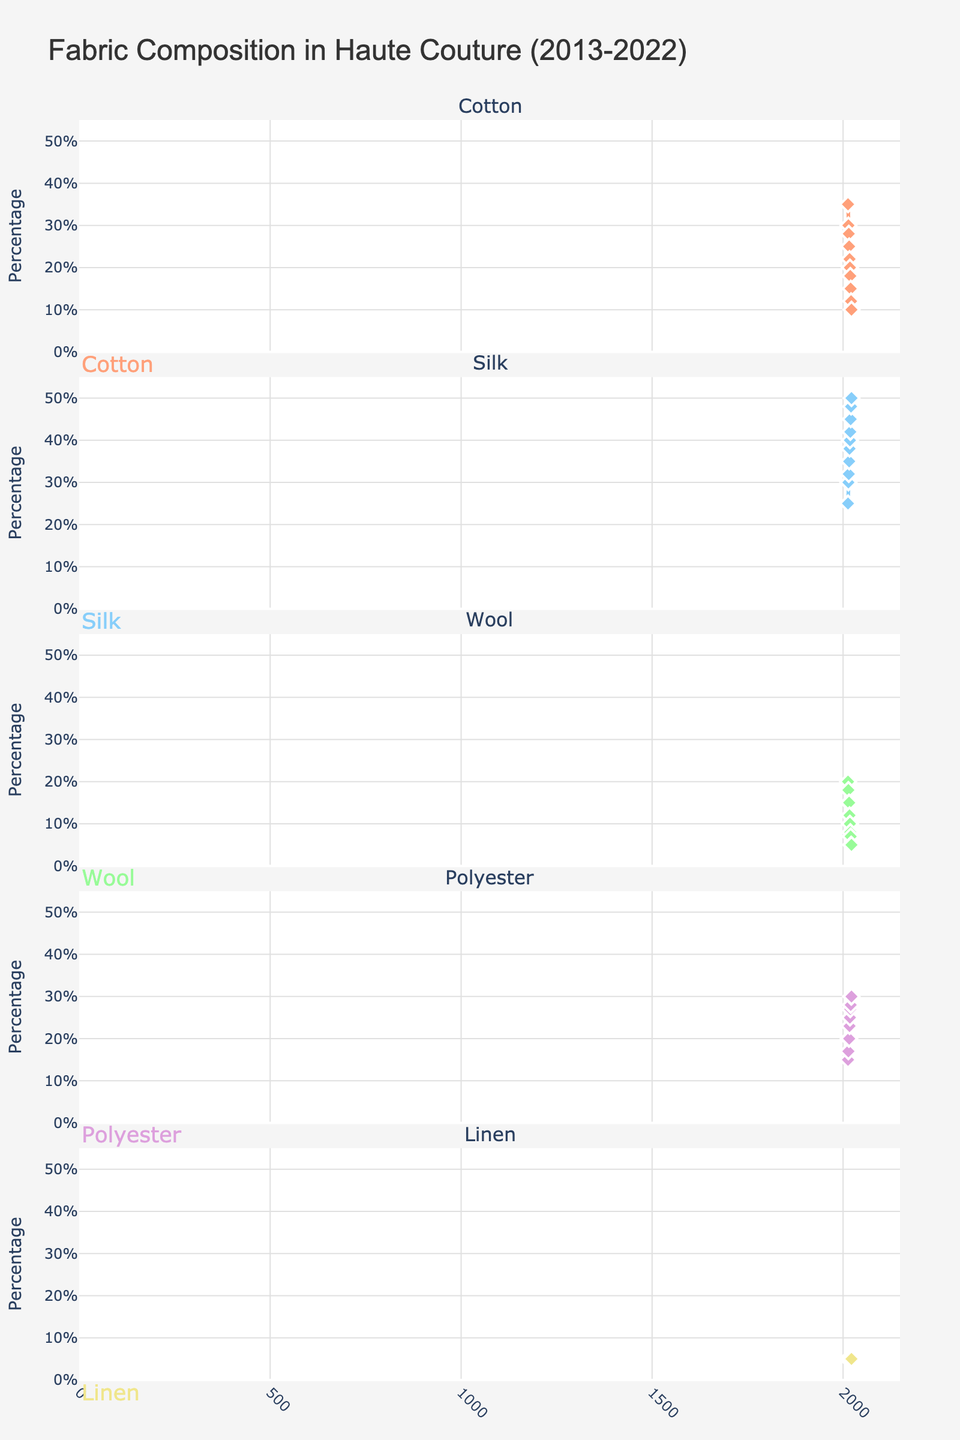How many years of data are represented in the figure? Count the years on the x-axis from the first year (2013) to the last year (2022). There are 10 distinct years shown in the figure.
Answer: 10 Which fabric shows the highest percentage in 2017? Look at the plot for 2017 and compare the five fabric subplots. Silk has the highest percentage with 38%.
Answer: Silk What is the overall trend for Cotton over the years? Observe the Cotton subplot from 2013 to 2022. The percentage trend shows a consistent decrease over the years.
Answer: Decreasing How many fabrics show an increase in percentage from 2018 to 2020? Compare the percentage values for all five fabrics between 2018 and 2020. Silk and Polyester show an increase in this period.
Answer: 2 Between which consecutive years does Wool show the largest drop in percentage? Look at the Wool subplot and find the consecutive years with the largest difference. The largest drop occurs between 2013 (20%) and 2014 (18%), which is a 2% drop.
Answer: 2013-2014 For which years is Linen's percentage constant? Check the Linen subplot for years with the same percentage. Linen shows a constant percentage of 5% from 2013 to 2022.
Answer: 2013-2022 Which fabric had the smallest percentage in 2015? Look at the percentages in 2015 and compare them for all fabrics. Wool had the smallest percentage with 15%.
Answer: Wool What is the average percentage of Polyester from 2013 to 2022? Sum the percentages of Polyester for all years and divide by 10. (15+17+20+20+23+25+27+28+30+30) / 10 = 23.5%.
Answer: 23.5% Which fabric's percentage increased the most from 2013 to 2022? Compare the percentage changes from 2013 to 2022 for all fabrics. Silk increased the most, from 25% to 50%, which is an increase of 25%.
Answer: Silk What's the total percentage of natural fabrics in 2020? Sum the percentages of Cotton, Silk, Wool, and Linen in 2020. (15+45+7+5) = 72%.
Answer: 72% 